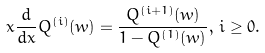Convert formula to latex. <formula><loc_0><loc_0><loc_500><loc_500>x \frac { d } { d x } Q ^ { ( i ) } ( w ) = \frac { Q ^ { ( i + 1 ) } ( w ) } { 1 - Q ^ { ( 1 ) } ( w ) } , \, i \geq 0 .</formula> 